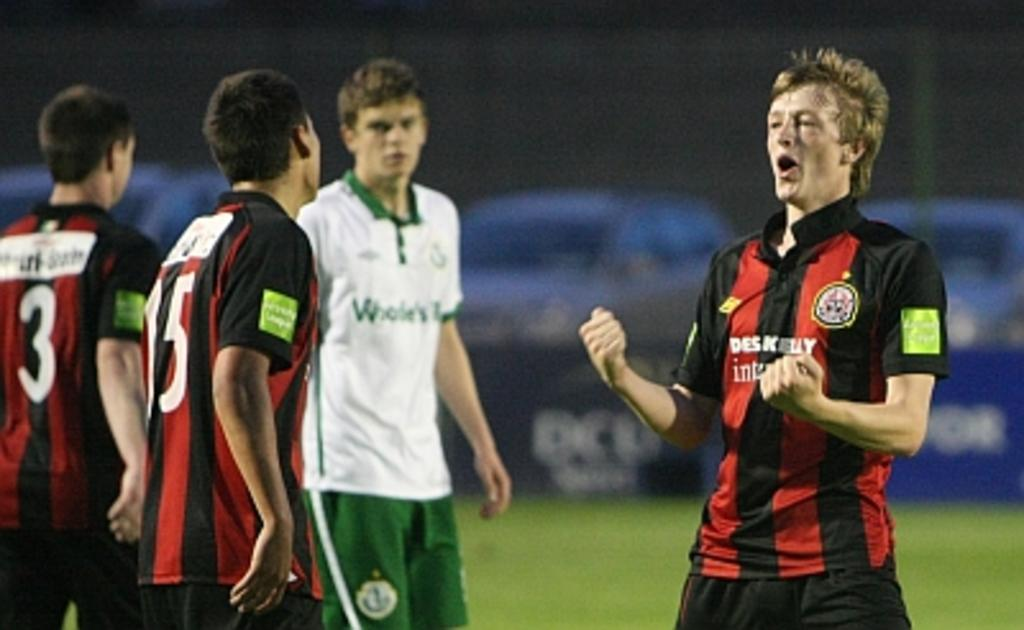<image>
Share a concise interpretation of the image provided. A player with Deskelly written on his jersey looks excited on the field 